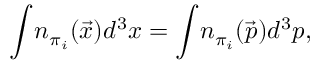<formula> <loc_0><loc_0><loc_500><loc_500>\int \, n _ { \pi _ { i } } ( \vec { x } ) d ^ { 3 } x = \int \, n _ { \pi _ { i } } ( \vec { p } ) d ^ { 3 } p ,</formula> 